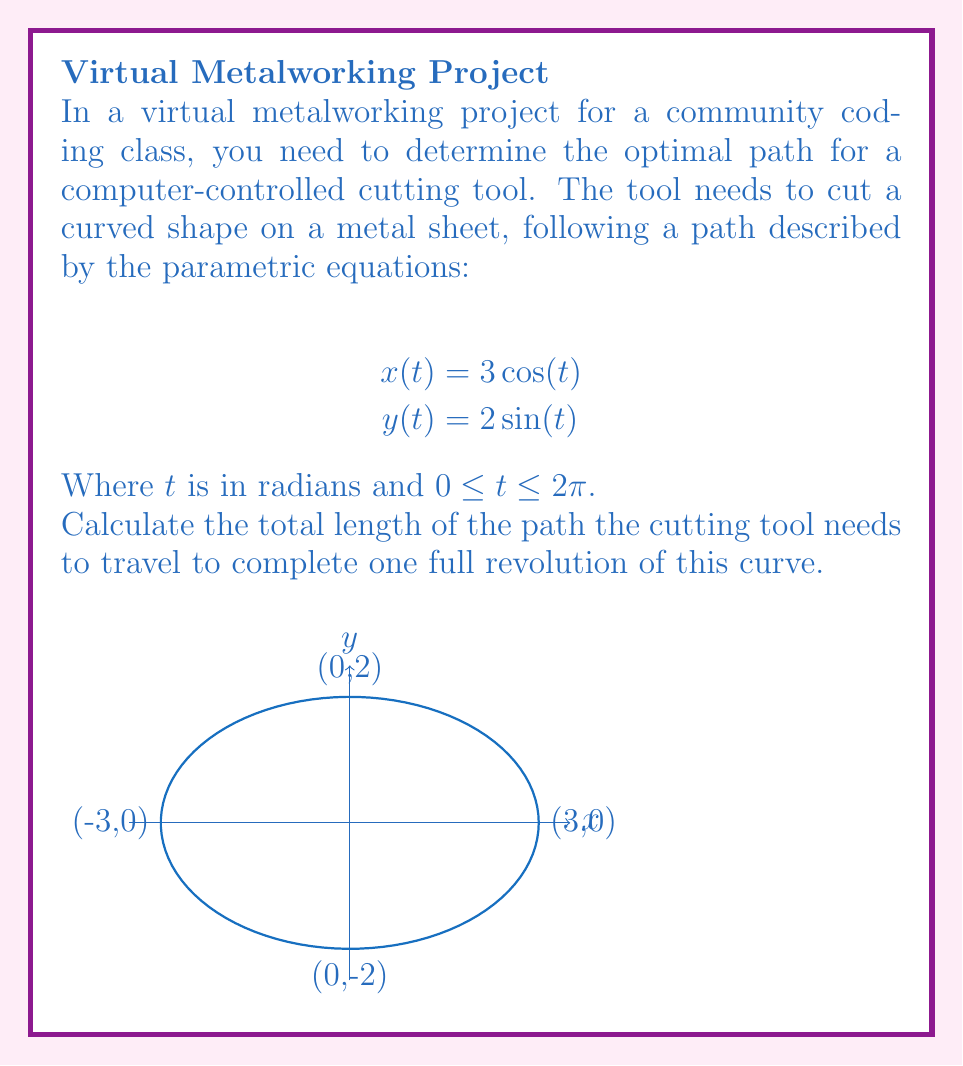Can you answer this question? To find the length of the path, we need to use the arc length formula for parametric equations:

$$L = \int_a^b \sqrt{\left(\frac{dx}{dt}\right)^2 + \left(\frac{dy}{dt}\right)^2} dt$$

Step 1: Find the derivatives $\frac{dx}{dt}$ and $\frac{dy}{dt}$
$$\frac{dx}{dt} = -3\sin(t)$$
$$\frac{dy}{dt} = 2\cos(t)$$

Step 2: Substitute these into the arc length formula
$$L = \int_0^{2\pi} \sqrt{(-3\sin(t))^2 + (2\cos(t))^2} dt$$

Step 3: Simplify the expression under the square root
$$L = \int_0^{2\pi} \sqrt{9\sin^2(t) + 4\cos^2(t)} dt$$

Step 4: Factor out the common term
$$L = \int_0^{2\pi} \sqrt{4(\frac{9}{4}\sin^2(t) + \cos^2(t))} dt$$

Step 5: Recognize that $\frac{9}{4}\sin^2(t) + \cos^2(t) = 1 + \frac{5}{4}\sin^2(t)$
$$L = \int_0^{2\pi} 2\sqrt{1 + \frac{5}{4}\sin^2(t)} dt$$

Step 6: This integral doesn't have an elementary antiderivative. We need to use the complete elliptic integral of the second kind, $E(k)$:

$$L = 4\sqrt{1 + \frac{5}{4}} \cdot E\left(\sqrt{\frac{5/4}{1 + 5/4}}\right)$$

Step 7: Simplify
$$L = 4\sqrt{\frac{9}{4}} \cdot E\left(\sqrt{\frac{5}{9}}\right) = 6 \cdot E\left(\sqrt{\frac{5}{9}}\right)$$

The value of $E\left(\sqrt{\frac{5}{9}}\right)$ is approximately 1.4736.

Step 8: Calculate the final result
$$L \approx 6 \cdot 1.4736 \approx 8.8416$$
Answer: $6E\left(\sqrt{\frac{5}{9}}\right) \approx 8.8416$ units 